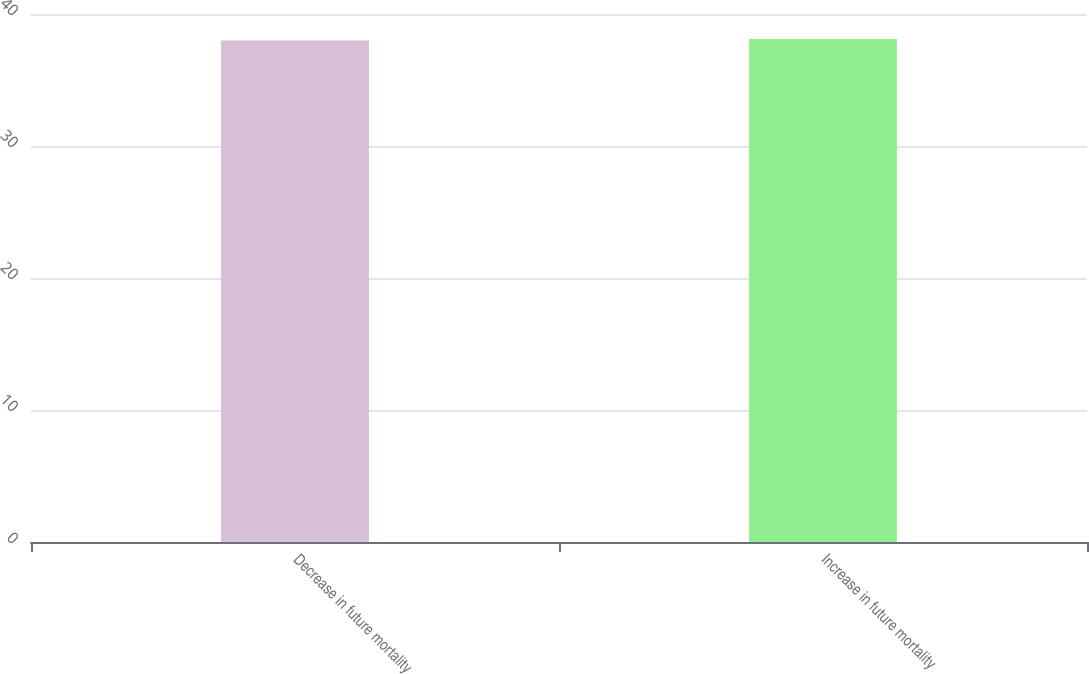<chart> <loc_0><loc_0><loc_500><loc_500><bar_chart><fcel>Decrease in future mortality<fcel>Increase in future mortality<nl><fcel>38<fcel>38.1<nl></chart> 